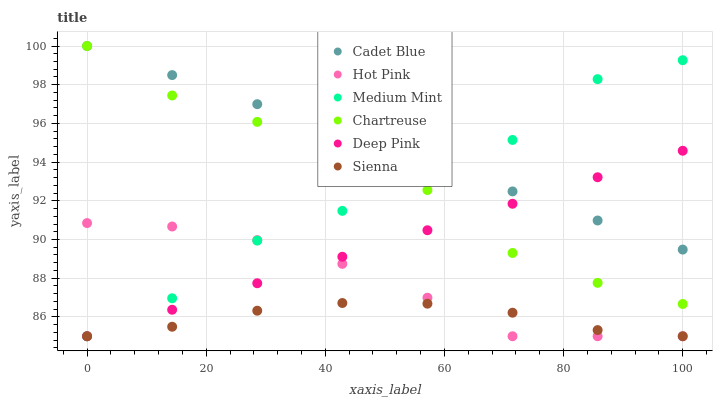Does Sienna have the minimum area under the curve?
Answer yes or no. Yes. Does Cadet Blue have the maximum area under the curve?
Answer yes or no. Yes. Does Hot Pink have the minimum area under the curve?
Answer yes or no. No. Does Hot Pink have the maximum area under the curve?
Answer yes or no. No. Is Deep Pink the smoothest?
Answer yes or no. Yes. Is Chartreuse the roughest?
Answer yes or no. Yes. Is Cadet Blue the smoothest?
Answer yes or no. No. Is Cadet Blue the roughest?
Answer yes or no. No. Does Medium Mint have the lowest value?
Answer yes or no. Yes. Does Cadet Blue have the lowest value?
Answer yes or no. No. Does Chartreuse have the highest value?
Answer yes or no. Yes. Does Hot Pink have the highest value?
Answer yes or no. No. Is Hot Pink less than Chartreuse?
Answer yes or no. Yes. Is Cadet Blue greater than Sienna?
Answer yes or no. Yes. Does Hot Pink intersect Sienna?
Answer yes or no. Yes. Is Hot Pink less than Sienna?
Answer yes or no. No. Is Hot Pink greater than Sienna?
Answer yes or no. No. Does Hot Pink intersect Chartreuse?
Answer yes or no. No. 